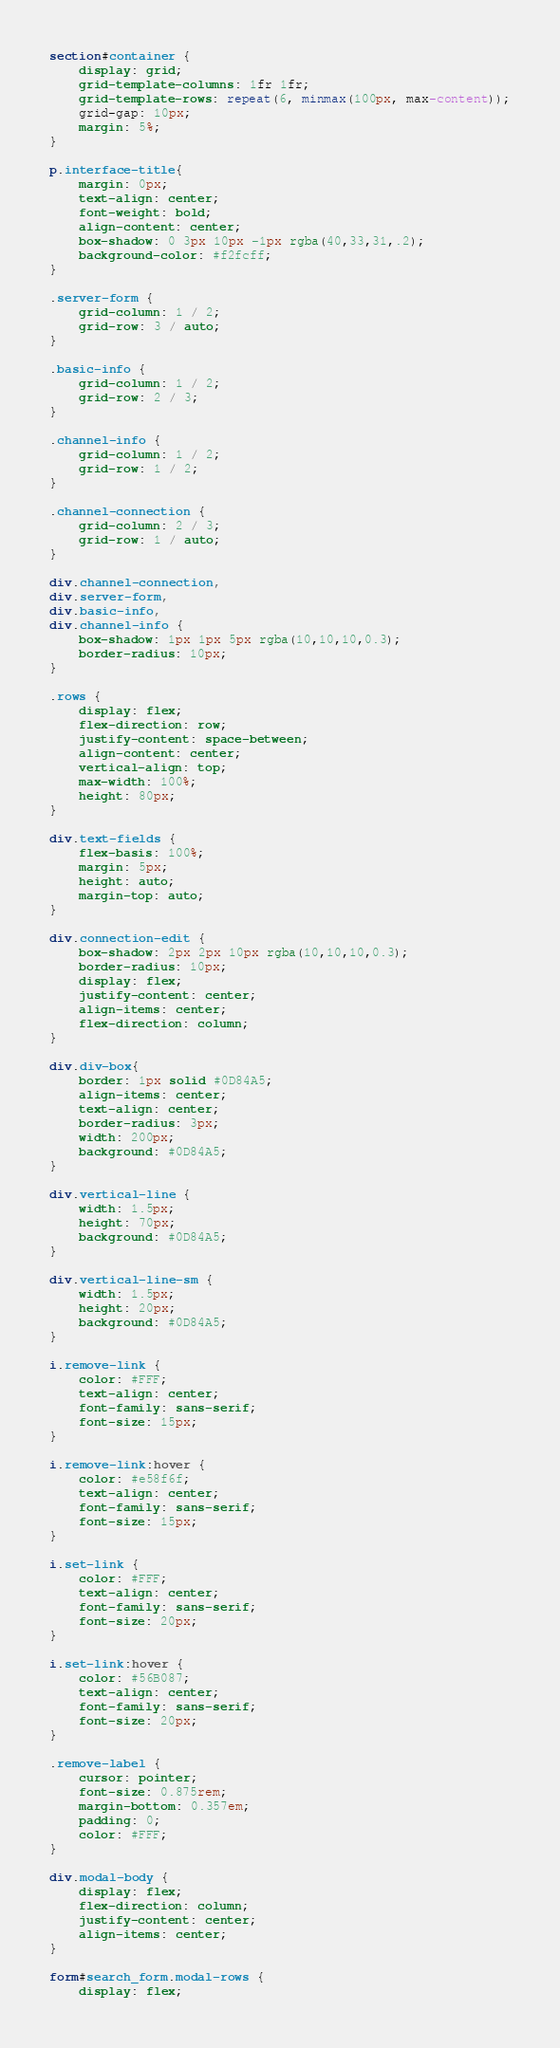Convert code to text. <code><loc_0><loc_0><loc_500><loc_500><_CSS_>
section#container {
    display: grid;
    grid-template-columns: 1fr 1fr;
    grid-template-rows: repeat(6, minmax(100px, max-content));
    grid-gap: 10px;
    margin: 5%;
}

p.interface-title{
    margin: 0px;
    text-align: center;
    font-weight: bold;
    align-content: center;
    box-shadow: 0 3px 10px -1px rgba(40,33,31,.2);
    background-color: #f2fcff;
}

.server-form {
    grid-column: 1 / 2;
    grid-row: 3 / auto;    
}

.basic-info {
    grid-column: 1 / 2;
    grid-row: 2 / 3;    
}

.channel-info {
    grid-column: 1 / 2; 
    grid-row: 1 / 2;
}

.channel-connection {
    grid-column: 2 / 3;
    grid-row: 1 / auto;    
}

div.channel-connection,
div.server-form,
div.basic-info,
div.channel-info {
    box-shadow: 1px 1px 5px rgba(10,10,10,0.3);
    border-radius: 10px;
}

.rows {
    display: flex;
    flex-direction: row;
    justify-content: space-between;
    align-content: center;
    vertical-align: top;
    max-width: 100%;
    height: 80px;
}

div.text-fields {
    flex-basis: 100%;
    margin: 5px;
    height: auto;
    margin-top: auto;
}

div.connection-edit {
    box-shadow: 2px 2px 10px rgba(10,10,10,0.3);
    border-radius: 10px;
    display: flex;
    justify-content: center;
    align-items: center;
    flex-direction: column;
}

div.div-box{
    border: 1px solid #0D84A5;
    align-items: center;
    text-align: center;
    border-radius: 3px;
    width: 200px;
    background: #0D84A5;
}

div.vertical-line {
    width: 1.5px;
    height: 70px;
    background: #0D84A5;
}

div.vertical-line-sm {
    width: 1.5px;
    height: 20px;
    background: #0D84A5;
}

i.remove-link {
    color: #FFF;
    text-align: center;
    font-family: sans-serif;
    font-size: 15px;
}

i.remove-link:hover {
    color: #e58f6f;
    text-align: center;
    font-family: sans-serif;
    font-size: 15px;
}

i.set-link {
    color: #FFF;
    text-align: center;
    font-family: sans-serif;
    font-size: 20px;
}

i.set-link:hover {
    color: #56B087;
    text-align: center;
    font-family: sans-serif;
    font-size: 20px;
}

.remove-label {
    cursor: pointer;
    font-size: 0.875rem;
    margin-bottom: 0.357em;
    padding: 0;
    color: #FFF;
}

div.modal-body {
    display: flex;
    flex-direction: column;
    justify-content: center;
    align-items: center;
}

form#search_form.modal-rows {
    display: flex;</code> 